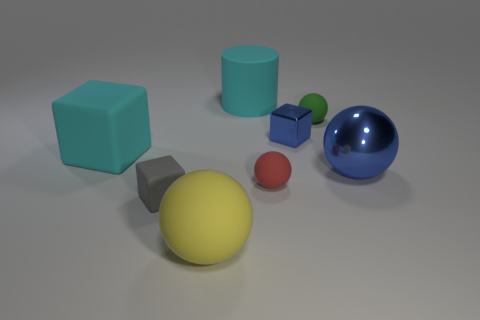Which objects are closer to the blue sphere? The green cube and the smaller green sphere are the closest to the blue sphere if we are observing from the given perspective. 